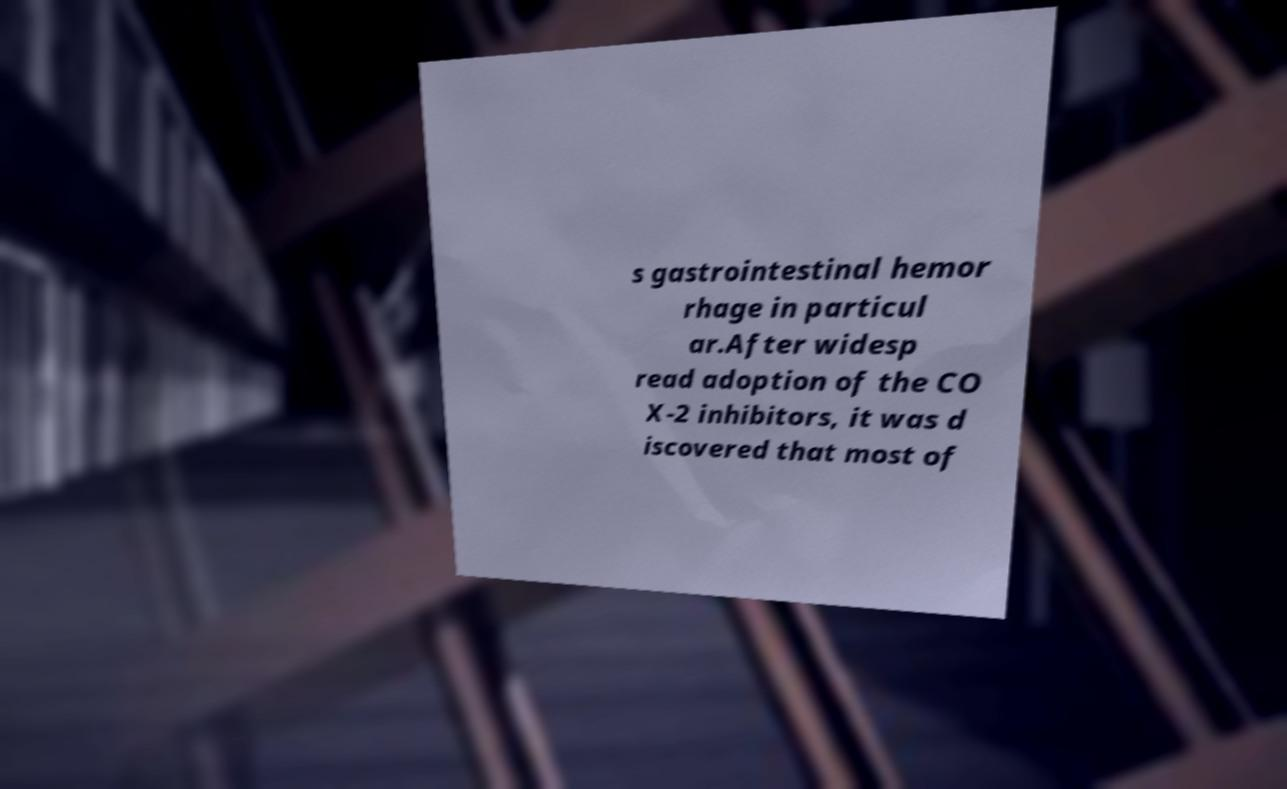Please read and relay the text visible in this image. What does it say? s gastrointestinal hemor rhage in particul ar.After widesp read adoption of the CO X-2 inhibitors, it was d iscovered that most of 